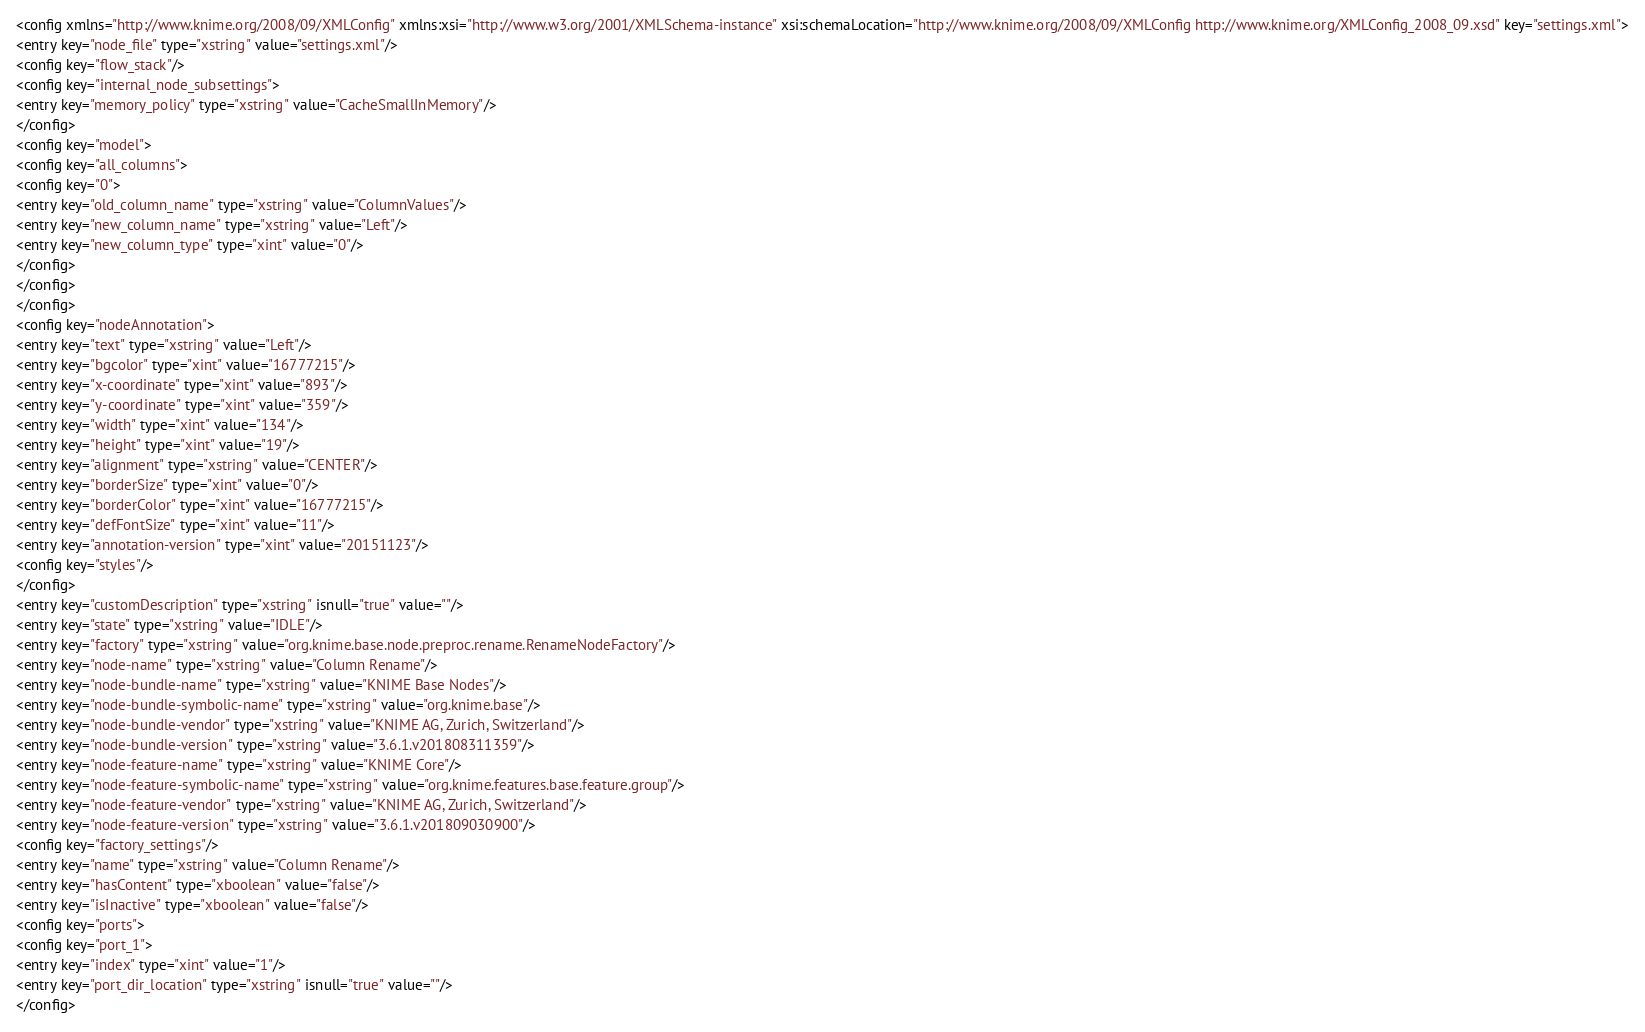<code> <loc_0><loc_0><loc_500><loc_500><_XML_><config xmlns="http://www.knime.org/2008/09/XMLConfig" xmlns:xsi="http://www.w3.org/2001/XMLSchema-instance" xsi:schemaLocation="http://www.knime.org/2008/09/XMLConfig http://www.knime.org/XMLConfig_2008_09.xsd" key="settings.xml">
<entry key="node_file" type="xstring" value="settings.xml"/>
<config key="flow_stack"/>
<config key="internal_node_subsettings">
<entry key="memory_policy" type="xstring" value="CacheSmallInMemory"/>
</config>
<config key="model">
<config key="all_columns">
<config key="0">
<entry key="old_column_name" type="xstring" value="ColumnValues"/>
<entry key="new_column_name" type="xstring" value="Left"/>
<entry key="new_column_type" type="xint" value="0"/>
</config>
</config>
</config>
<config key="nodeAnnotation">
<entry key="text" type="xstring" value="Left"/>
<entry key="bgcolor" type="xint" value="16777215"/>
<entry key="x-coordinate" type="xint" value="893"/>
<entry key="y-coordinate" type="xint" value="359"/>
<entry key="width" type="xint" value="134"/>
<entry key="height" type="xint" value="19"/>
<entry key="alignment" type="xstring" value="CENTER"/>
<entry key="borderSize" type="xint" value="0"/>
<entry key="borderColor" type="xint" value="16777215"/>
<entry key="defFontSize" type="xint" value="11"/>
<entry key="annotation-version" type="xint" value="20151123"/>
<config key="styles"/>
</config>
<entry key="customDescription" type="xstring" isnull="true" value=""/>
<entry key="state" type="xstring" value="IDLE"/>
<entry key="factory" type="xstring" value="org.knime.base.node.preproc.rename.RenameNodeFactory"/>
<entry key="node-name" type="xstring" value="Column Rename"/>
<entry key="node-bundle-name" type="xstring" value="KNIME Base Nodes"/>
<entry key="node-bundle-symbolic-name" type="xstring" value="org.knime.base"/>
<entry key="node-bundle-vendor" type="xstring" value="KNIME AG, Zurich, Switzerland"/>
<entry key="node-bundle-version" type="xstring" value="3.6.1.v201808311359"/>
<entry key="node-feature-name" type="xstring" value="KNIME Core"/>
<entry key="node-feature-symbolic-name" type="xstring" value="org.knime.features.base.feature.group"/>
<entry key="node-feature-vendor" type="xstring" value="KNIME AG, Zurich, Switzerland"/>
<entry key="node-feature-version" type="xstring" value="3.6.1.v201809030900"/>
<config key="factory_settings"/>
<entry key="name" type="xstring" value="Column Rename"/>
<entry key="hasContent" type="xboolean" value="false"/>
<entry key="isInactive" type="xboolean" value="false"/>
<config key="ports">
<config key="port_1">
<entry key="index" type="xint" value="1"/>
<entry key="port_dir_location" type="xstring" isnull="true" value=""/>
</config></code> 